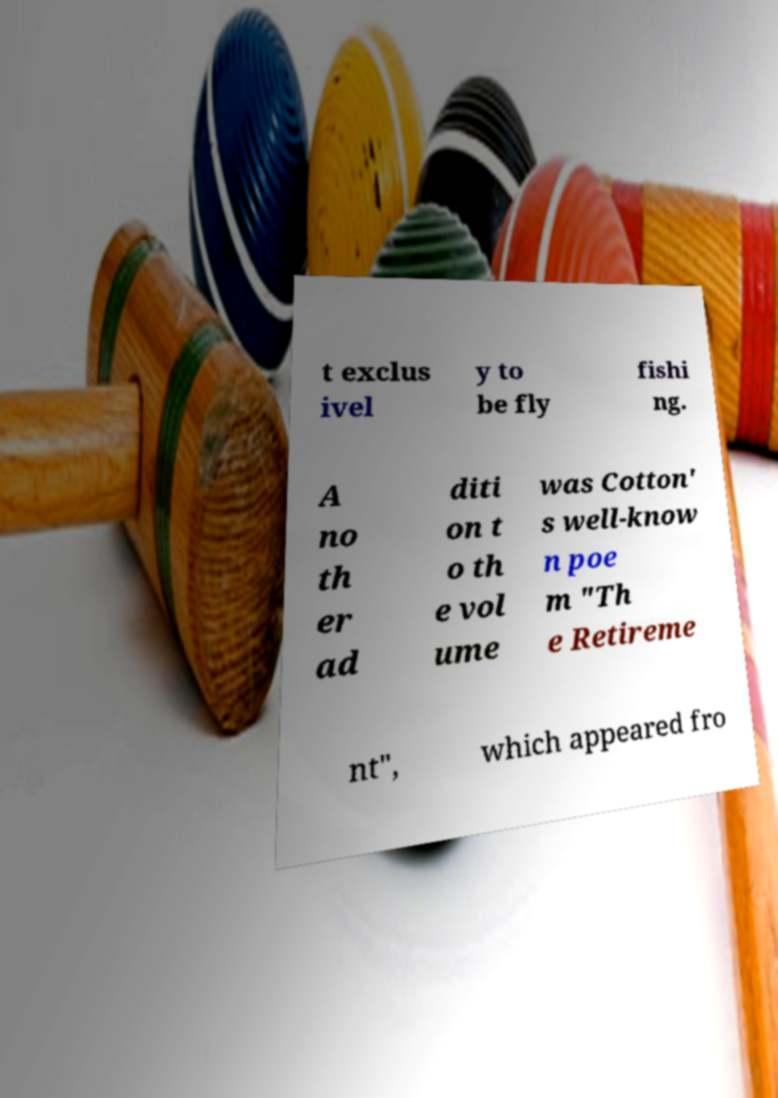Please identify and transcribe the text found in this image. t exclus ivel y to be fly fishi ng. A no th er ad diti on t o th e vol ume was Cotton' s well-know n poe m "Th e Retireme nt", which appeared fro 